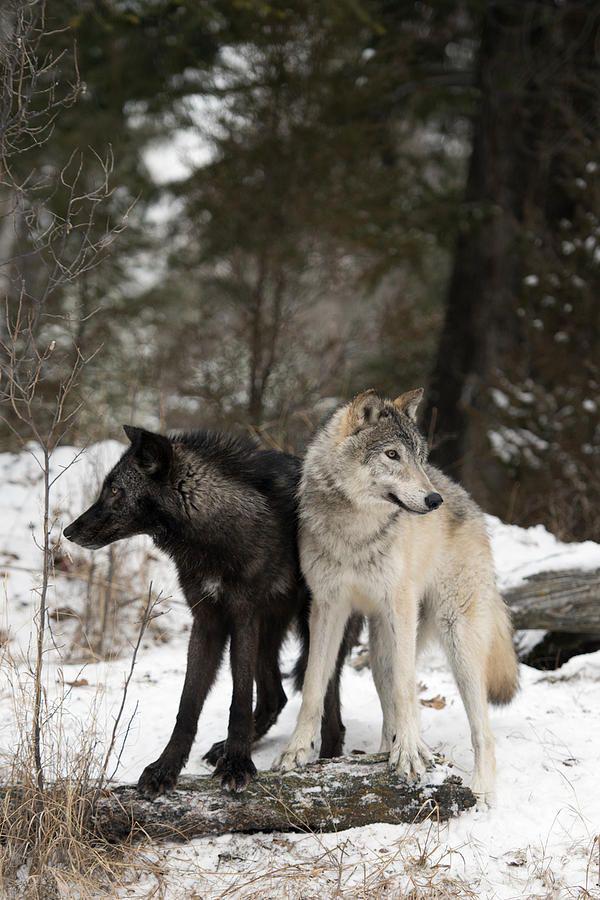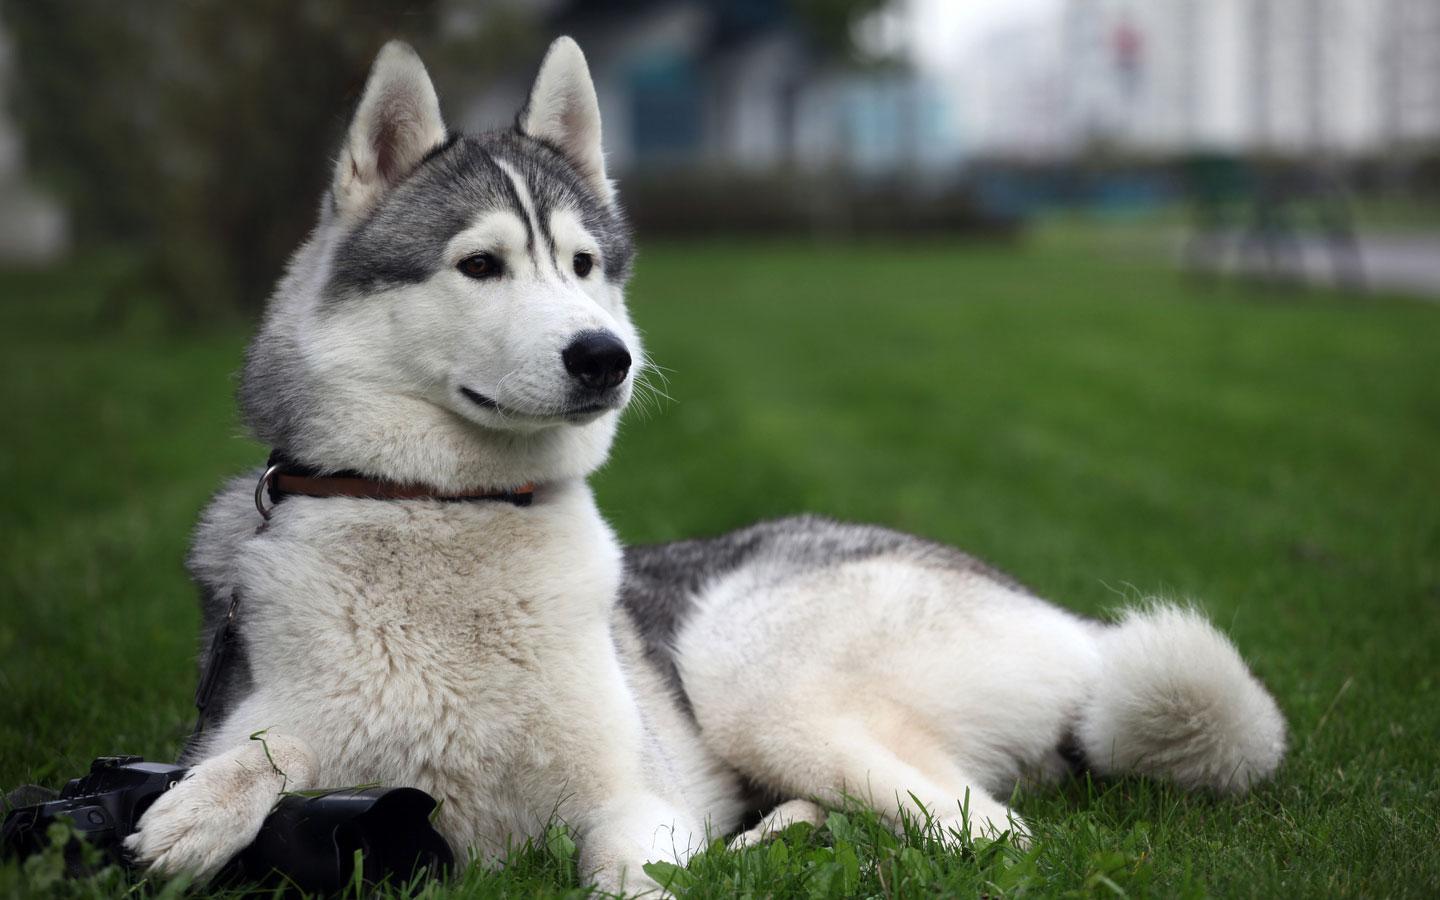The first image is the image on the left, the second image is the image on the right. Assess this claim about the two images: "You can clearly see there are more than three wolves or dogs.". Correct or not? Answer yes or no. No. The first image is the image on the left, the second image is the image on the right. Assess this claim about the two images: "There are at most 3 wolves.". Correct or not? Answer yes or no. Yes. 